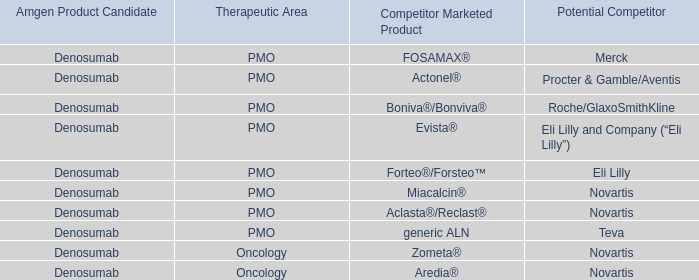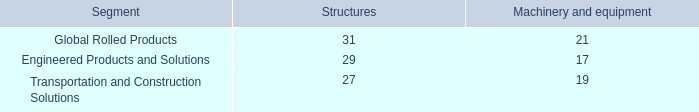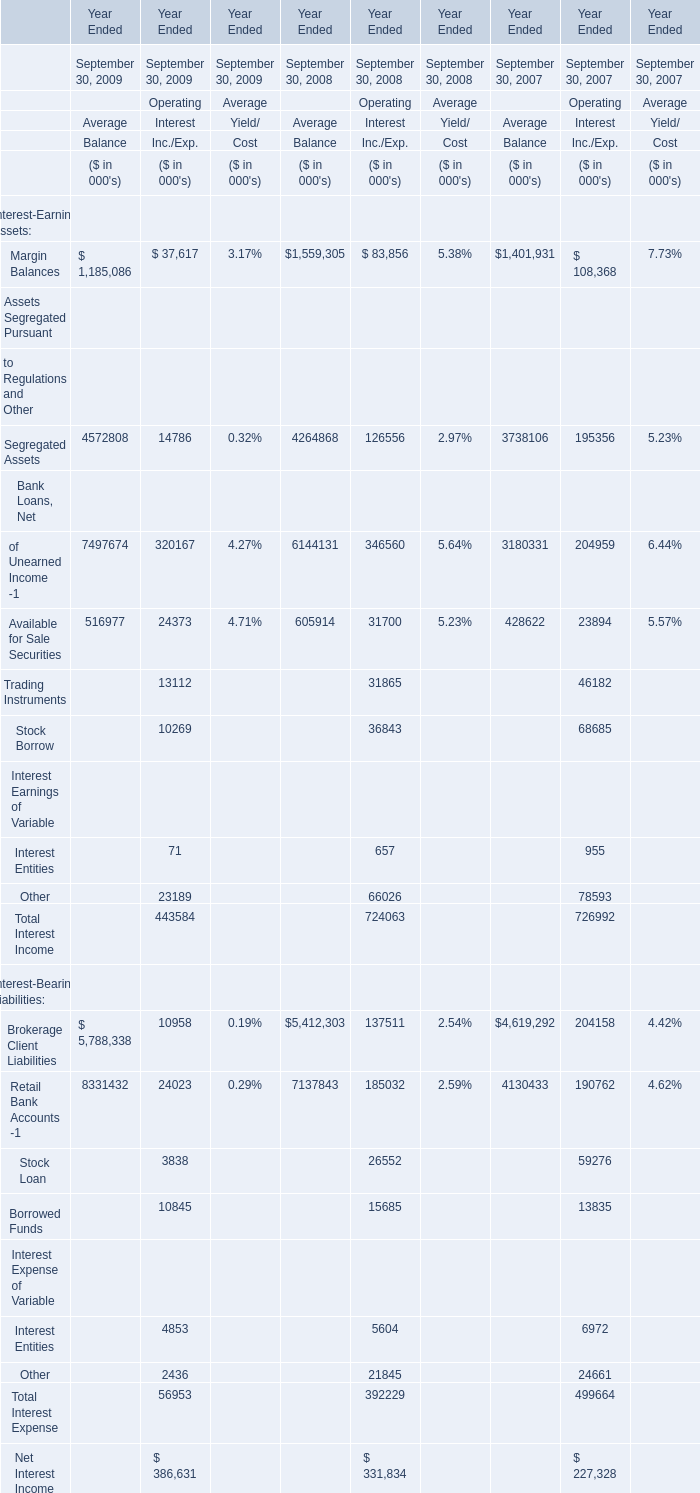what is the difference between firth rixson's goodwill and the rti's? 
Computations: (1801 - 298)
Answer: 1503.0. 